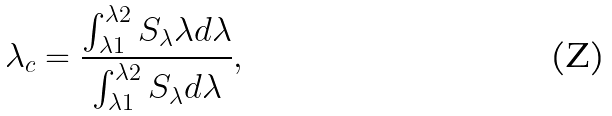<formula> <loc_0><loc_0><loc_500><loc_500>\lambda _ { c } = \frac { \int _ { \lambda 1 } ^ { \lambda 2 } S _ { \lambda } \lambda d \lambda } { \int _ { \lambda 1 } ^ { \lambda 2 } S _ { \lambda } d \lambda } ,</formula> 